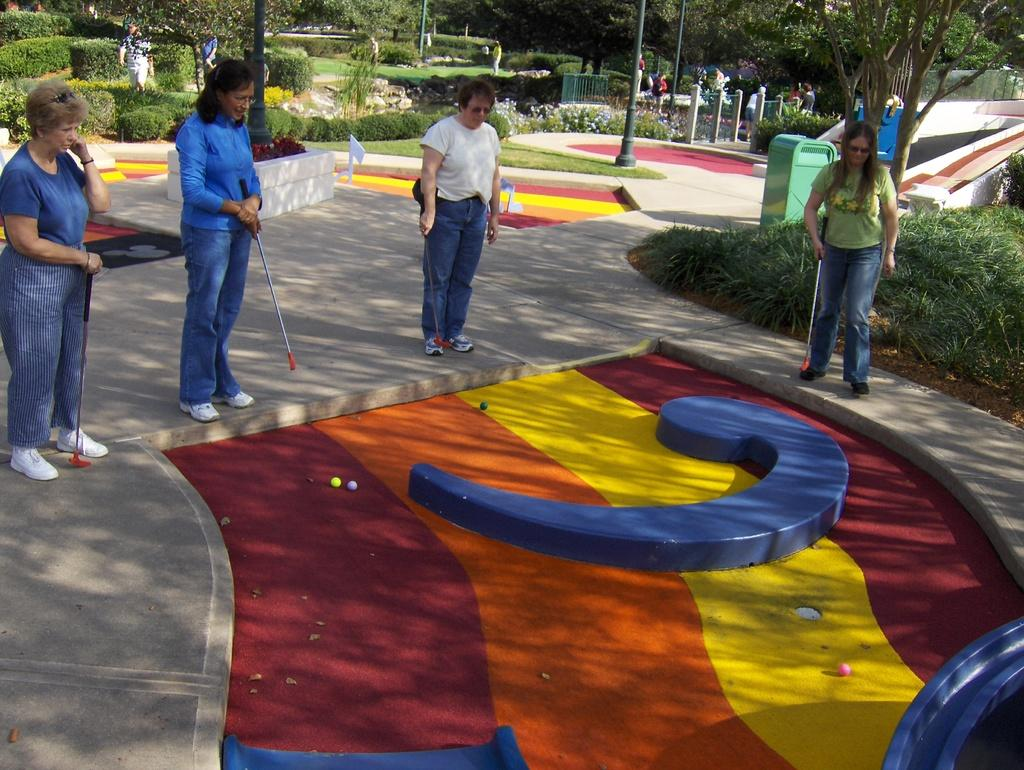What are the people in the image doing? The people in the image are playing games. What type of environment is depicted in the image? There are trees and grass visible in the image, suggesting a natural setting. Can you describe the surface on which the people are standing? The people are standing on the floor in the image. What type of snail can be seen crawling on the print in the image? There is no snail or print present in the image. How many clouds are visible in the image? There is no mention of clouds in the provided facts, so we cannot determine the number of clouds visible in the image. 